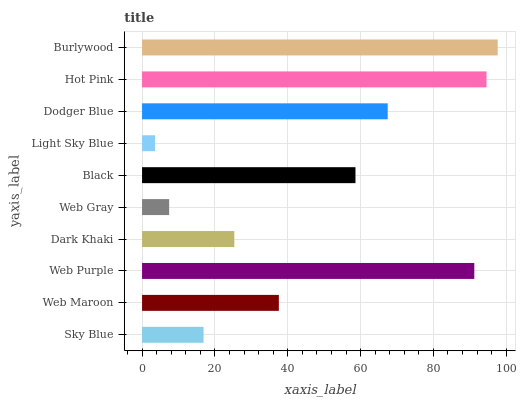Is Light Sky Blue the minimum?
Answer yes or no. Yes. Is Burlywood the maximum?
Answer yes or no. Yes. Is Web Maroon the minimum?
Answer yes or no. No. Is Web Maroon the maximum?
Answer yes or no. No. Is Web Maroon greater than Sky Blue?
Answer yes or no. Yes. Is Sky Blue less than Web Maroon?
Answer yes or no. Yes. Is Sky Blue greater than Web Maroon?
Answer yes or no. No. Is Web Maroon less than Sky Blue?
Answer yes or no. No. Is Black the high median?
Answer yes or no. Yes. Is Web Maroon the low median?
Answer yes or no. Yes. Is Light Sky Blue the high median?
Answer yes or no. No. Is Sky Blue the low median?
Answer yes or no. No. 